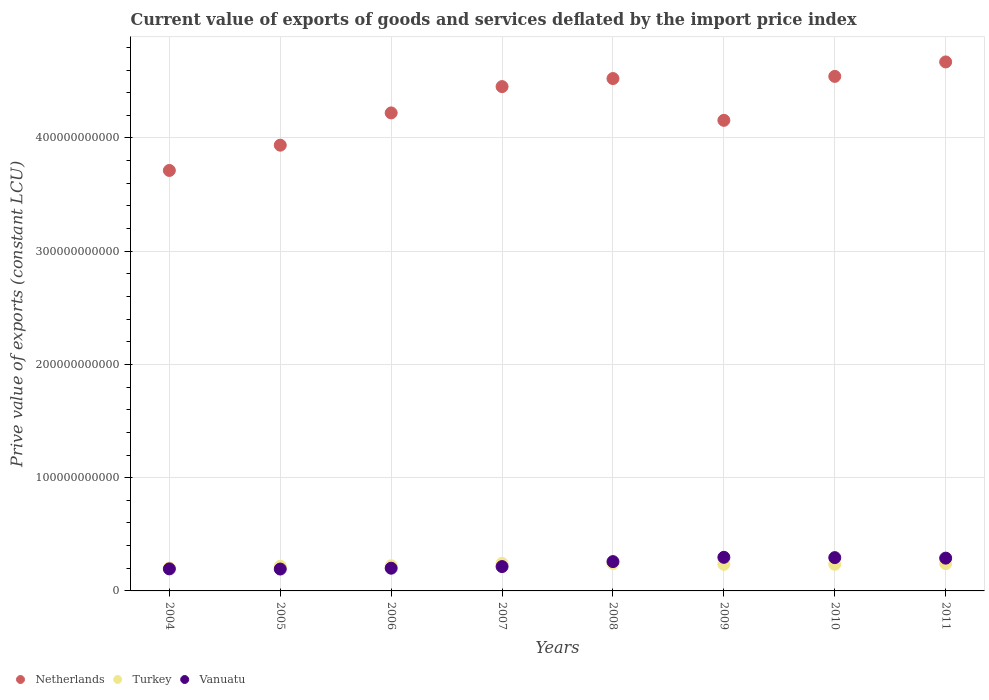How many different coloured dotlines are there?
Your response must be concise. 3. What is the prive value of exports in Turkey in 2010?
Offer a terse response. 2.35e+1. Across all years, what is the maximum prive value of exports in Turkey?
Ensure brevity in your answer.  2.43e+1. Across all years, what is the minimum prive value of exports in Vanuatu?
Provide a succinct answer. 1.93e+1. In which year was the prive value of exports in Vanuatu minimum?
Offer a very short reply. 2005. What is the total prive value of exports in Vanuatu in the graph?
Your answer should be very brief. 1.94e+11. What is the difference between the prive value of exports in Vanuatu in 2007 and that in 2008?
Provide a succinct answer. -4.38e+09. What is the difference between the prive value of exports in Turkey in 2011 and the prive value of exports in Vanuatu in 2007?
Make the answer very short. 2.60e+09. What is the average prive value of exports in Vanuatu per year?
Offer a terse response. 2.43e+1. In the year 2005, what is the difference between the prive value of exports in Vanuatu and prive value of exports in Turkey?
Ensure brevity in your answer.  -2.48e+09. What is the ratio of the prive value of exports in Turkey in 2004 to that in 2006?
Your answer should be very brief. 0.91. Is the prive value of exports in Vanuatu in 2005 less than that in 2006?
Provide a succinct answer. Yes. What is the difference between the highest and the second highest prive value of exports in Vanuatu?
Offer a terse response. 2.61e+08. What is the difference between the highest and the lowest prive value of exports in Turkey?
Provide a short and direct response. 4.02e+09. In how many years, is the prive value of exports in Vanuatu greater than the average prive value of exports in Vanuatu taken over all years?
Offer a very short reply. 4. Is it the case that in every year, the sum of the prive value of exports in Vanuatu and prive value of exports in Netherlands  is greater than the prive value of exports in Turkey?
Your response must be concise. Yes. What is the difference between two consecutive major ticks on the Y-axis?
Offer a very short reply. 1.00e+11. Where does the legend appear in the graph?
Your response must be concise. Bottom left. How many legend labels are there?
Make the answer very short. 3. What is the title of the graph?
Provide a succinct answer. Current value of exports of goods and services deflated by the import price index. Does "Cameroon" appear as one of the legend labels in the graph?
Provide a succinct answer. No. What is the label or title of the Y-axis?
Give a very brief answer. Prive value of exports (constant LCU). What is the Prive value of exports (constant LCU) of Netherlands in 2004?
Offer a terse response. 3.71e+11. What is the Prive value of exports (constant LCU) of Turkey in 2004?
Your response must be concise. 2.03e+1. What is the Prive value of exports (constant LCU) in Vanuatu in 2004?
Keep it short and to the point. 1.95e+1. What is the Prive value of exports (constant LCU) of Netherlands in 2005?
Give a very brief answer. 3.94e+11. What is the Prive value of exports (constant LCU) in Turkey in 2005?
Provide a succinct answer. 2.18e+1. What is the Prive value of exports (constant LCU) of Vanuatu in 2005?
Give a very brief answer. 1.93e+1. What is the Prive value of exports (constant LCU) of Netherlands in 2006?
Keep it short and to the point. 4.22e+11. What is the Prive value of exports (constant LCU) of Turkey in 2006?
Your response must be concise. 2.22e+1. What is the Prive value of exports (constant LCU) in Vanuatu in 2006?
Offer a very short reply. 2.01e+1. What is the Prive value of exports (constant LCU) of Netherlands in 2007?
Keep it short and to the point. 4.45e+11. What is the Prive value of exports (constant LCU) in Turkey in 2007?
Make the answer very short. 2.43e+1. What is the Prive value of exports (constant LCU) in Vanuatu in 2007?
Keep it short and to the point. 2.15e+1. What is the Prive value of exports (constant LCU) of Netherlands in 2008?
Offer a very short reply. 4.52e+11. What is the Prive value of exports (constant LCU) in Turkey in 2008?
Ensure brevity in your answer.  2.42e+1. What is the Prive value of exports (constant LCU) in Vanuatu in 2008?
Your answer should be compact. 2.59e+1. What is the Prive value of exports (constant LCU) in Netherlands in 2009?
Your answer should be compact. 4.16e+11. What is the Prive value of exports (constant LCU) in Turkey in 2009?
Provide a short and direct response. 2.35e+1. What is the Prive value of exports (constant LCU) of Vanuatu in 2009?
Ensure brevity in your answer.  2.97e+1. What is the Prive value of exports (constant LCU) in Netherlands in 2010?
Make the answer very short. 4.54e+11. What is the Prive value of exports (constant LCU) in Turkey in 2010?
Offer a terse response. 2.35e+1. What is the Prive value of exports (constant LCU) of Vanuatu in 2010?
Offer a very short reply. 2.94e+1. What is the Prive value of exports (constant LCU) of Netherlands in 2011?
Offer a terse response. 4.67e+11. What is the Prive value of exports (constant LCU) of Turkey in 2011?
Keep it short and to the point. 2.41e+1. What is the Prive value of exports (constant LCU) of Vanuatu in 2011?
Offer a very short reply. 2.90e+1. Across all years, what is the maximum Prive value of exports (constant LCU) in Netherlands?
Give a very brief answer. 4.67e+11. Across all years, what is the maximum Prive value of exports (constant LCU) in Turkey?
Give a very brief answer. 2.43e+1. Across all years, what is the maximum Prive value of exports (constant LCU) of Vanuatu?
Offer a terse response. 2.97e+1. Across all years, what is the minimum Prive value of exports (constant LCU) in Netherlands?
Ensure brevity in your answer.  3.71e+11. Across all years, what is the minimum Prive value of exports (constant LCU) of Turkey?
Ensure brevity in your answer.  2.03e+1. Across all years, what is the minimum Prive value of exports (constant LCU) of Vanuatu?
Give a very brief answer. 1.93e+1. What is the total Prive value of exports (constant LCU) of Netherlands in the graph?
Keep it short and to the point. 3.42e+12. What is the total Prive value of exports (constant LCU) of Turkey in the graph?
Your response must be concise. 1.84e+11. What is the total Prive value of exports (constant LCU) in Vanuatu in the graph?
Offer a very short reply. 1.94e+11. What is the difference between the Prive value of exports (constant LCU) of Netherlands in 2004 and that in 2005?
Make the answer very short. -2.23e+1. What is the difference between the Prive value of exports (constant LCU) in Turkey in 2004 and that in 2005?
Your answer should be very brief. -1.52e+09. What is the difference between the Prive value of exports (constant LCU) in Vanuatu in 2004 and that in 2005?
Give a very brief answer. 1.50e+08. What is the difference between the Prive value of exports (constant LCU) of Netherlands in 2004 and that in 2006?
Your answer should be compact. -5.08e+1. What is the difference between the Prive value of exports (constant LCU) of Turkey in 2004 and that in 2006?
Your response must be concise. -1.94e+09. What is the difference between the Prive value of exports (constant LCU) of Vanuatu in 2004 and that in 2006?
Provide a short and direct response. -5.93e+08. What is the difference between the Prive value of exports (constant LCU) in Netherlands in 2004 and that in 2007?
Give a very brief answer. -7.41e+1. What is the difference between the Prive value of exports (constant LCU) in Turkey in 2004 and that in 2007?
Your answer should be very brief. -4.02e+09. What is the difference between the Prive value of exports (constant LCU) in Vanuatu in 2004 and that in 2007?
Provide a short and direct response. -2.04e+09. What is the difference between the Prive value of exports (constant LCU) of Netherlands in 2004 and that in 2008?
Your answer should be very brief. -8.12e+1. What is the difference between the Prive value of exports (constant LCU) of Turkey in 2004 and that in 2008?
Keep it short and to the point. -3.92e+09. What is the difference between the Prive value of exports (constant LCU) in Vanuatu in 2004 and that in 2008?
Your answer should be very brief. -6.42e+09. What is the difference between the Prive value of exports (constant LCU) in Netherlands in 2004 and that in 2009?
Give a very brief answer. -4.43e+1. What is the difference between the Prive value of exports (constant LCU) in Turkey in 2004 and that in 2009?
Offer a terse response. -3.19e+09. What is the difference between the Prive value of exports (constant LCU) in Vanuatu in 2004 and that in 2009?
Give a very brief answer. -1.02e+1. What is the difference between the Prive value of exports (constant LCU) of Netherlands in 2004 and that in 2010?
Make the answer very short. -8.31e+1. What is the difference between the Prive value of exports (constant LCU) in Turkey in 2004 and that in 2010?
Provide a succinct answer. -3.24e+09. What is the difference between the Prive value of exports (constant LCU) of Vanuatu in 2004 and that in 2010?
Your response must be concise. -9.94e+09. What is the difference between the Prive value of exports (constant LCU) in Netherlands in 2004 and that in 2011?
Offer a terse response. -9.59e+1. What is the difference between the Prive value of exports (constant LCU) of Turkey in 2004 and that in 2011?
Make the answer very short. -3.84e+09. What is the difference between the Prive value of exports (constant LCU) in Vanuatu in 2004 and that in 2011?
Make the answer very short. -9.48e+09. What is the difference between the Prive value of exports (constant LCU) of Netherlands in 2005 and that in 2006?
Your response must be concise. -2.85e+1. What is the difference between the Prive value of exports (constant LCU) of Turkey in 2005 and that in 2006?
Provide a succinct answer. -4.16e+08. What is the difference between the Prive value of exports (constant LCU) of Vanuatu in 2005 and that in 2006?
Your response must be concise. -7.43e+08. What is the difference between the Prive value of exports (constant LCU) in Netherlands in 2005 and that in 2007?
Keep it short and to the point. -5.17e+1. What is the difference between the Prive value of exports (constant LCU) of Turkey in 2005 and that in 2007?
Provide a succinct answer. -2.49e+09. What is the difference between the Prive value of exports (constant LCU) in Vanuatu in 2005 and that in 2007?
Ensure brevity in your answer.  -2.19e+09. What is the difference between the Prive value of exports (constant LCU) of Netherlands in 2005 and that in 2008?
Ensure brevity in your answer.  -5.88e+1. What is the difference between the Prive value of exports (constant LCU) in Turkey in 2005 and that in 2008?
Give a very brief answer. -2.39e+09. What is the difference between the Prive value of exports (constant LCU) of Vanuatu in 2005 and that in 2008?
Make the answer very short. -6.57e+09. What is the difference between the Prive value of exports (constant LCU) in Netherlands in 2005 and that in 2009?
Provide a short and direct response. -2.19e+1. What is the difference between the Prive value of exports (constant LCU) in Turkey in 2005 and that in 2009?
Make the answer very short. -1.66e+09. What is the difference between the Prive value of exports (constant LCU) in Vanuatu in 2005 and that in 2009?
Keep it short and to the point. -1.04e+1. What is the difference between the Prive value of exports (constant LCU) of Netherlands in 2005 and that in 2010?
Your answer should be compact. -6.08e+1. What is the difference between the Prive value of exports (constant LCU) in Turkey in 2005 and that in 2010?
Your answer should be compact. -1.71e+09. What is the difference between the Prive value of exports (constant LCU) of Vanuatu in 2005 and that in 2010?
Your answer should be compact. -1.01e+1. What is the difference between the Prive value of exports (constant LCU) in Netherlands in 2005 and that in 2011?
Offer a very short reply. -7.35e+1. What is the difference between the Prive value of exports (constant LCU) in Turkey in 2005 and that in 2011?
Provide a succinct answer. -2.31e+09. What is the difference between the Prive value of exports (constant LCU) in Vanuatu in 2005 and that in 2011?
Provide a succinct answer. -9.63e+09. What is the difference between the Prive value of exports (constant LCU) of Netherlands in 2006 and that in 2007?
Your response must be concise. -2.32e+1. What is the difference between the Prive value of exports (constant LCU) in Turkey in 2006 and that in 2007?
Your answer should be very brief. -2.08e+09. What is the difference between the Prive value of exports (constant LCU) in Vanuatu in 2006 and that in 2007?
Give a very brief answer. -1.45e+09. What is the difference between the Prive value of exports (constant LCU) of Netherlands in 2006 and that in 2008?
Give a very brief answer. -3.03e+1. What is the difference between the Prive value of exports (constant LCU) of Turkey in 2006 and that in 2008?
Your answer should be very brief. -1.97e+09. What is the difference between the Prive value of exports (constant LCU) in Vanuatu in 2006 and that in 2008?
Your answer should be very brief. -5.82e+09. What is the difference between the Prive value of exports (constant LCU) in Netherlands in 2006 and that in 2009?
Make the answer very short. 6.55e+09. What is the difference between the Prive value of exports (constant LCU) of Turkey in 2006 and that in 2009?
Offer a very short reply. -1.25e+09. What is the difference between the Prive value of exports (constant LCU) in Vanuatu in 2006 and that in 2009?
Your response must be concise. -9.61e+09. What is the difference between the Prive value of exports (constant LCU) of Netherlands in 2006 and that in 2010?
Give a very brief answer. -3.23e+1. What is the difference between the Prive value of exports (constant LCU) of Turkey in 2006 and that in 2010?
Give a very brief answer. -1.29e+09. What is the difference between the Prive value of exports (constant LCU) of Vanuatu in 2006 and that in 2010?
Ensure brevity in your answer.  -9.35e+09. What is the difference between the Prive value of exports (constant LCU) in Netherlands in 2006 and that in 2011?
Provide a short and direct response. -4.50e+1. What is the difference between the Prive value of exports (constant LCU) in Turkey in 2006 and that in 2011?
Make the answer very short. -1.90e+09. What is the difference between the Prive value of exports (constant LCU) in Vanuatu in 2006 and that in 2011?
Your response must be concise. -8.89e+09. What is the difference between the Prive value of exports (constant LCU) in Netherlands in 2007 and that in 2008?
Provide a succinct answer. -7.11e+09. What is the difference between the Prive value of exports (constant LCU) of Turkey in 2007 and that in 2008?
Provide a short and direct response. 1.04e+08. What is the difference between the Prive value of exports (constant LCU) in Vanuatu in 2007 and that in 2008?
Your answer should be compact. -4.38e+09. What is the difference between the Prive value of exports (constant LCU) in Netherlands in 2007 and that in 2009?
Offer a very short reply. 2.98e+1. What is the difference between the Prive value of exports (constant LCU) in Turkey in 2007 and that in 2009?
Offer a very short reply. 8.31e+08. What is the difference between the Prive value of exports (constant LCU) in Vanuatu in 2007 and that in 2009?
Make the answer very short. -8.16e+09. What is the difference between the Prive value of exports (constant LCU) of Netherlands in 2007 and that in 2010?
Give a very brief answer. -9.02e+09. What is the difference between the Prive value of exports (constant LCU) of Turkey in 2007 and that in 2010?
Your answer should be very brief. 7.84e+08. What is the difference between the Prive value of exports (constant LCU) of Vanuatu in 2007 and that in 2010?
Make the answer very short. -7.90e+09. What is the difference between the Prive value of exports (constant LCU) of Netherlands in 2007 and that in 2011?
Your response must be concise. -2.18e+1. What is the difference between the Prive value of exports (constant LCU) in Turkey in 2007 and that in 2011?
Your answer should be very brief. 1.84e+08. What is the difference between the Prive value of exports (constant LCU) of Vanuatu in 2007 and that in 2011?
Give a very brief answer. -7.44e+09. What is the difference between the Prive value of exports (constant LCU) in Netherlands in 2008 and that in 2009?
Provide a succinct answer. 3.69e+1. What is the difference between the Prive value of exports (constant LCU) in Turkey in 2008 and that in 2009?
Ensure brevity in your answer.  7.27e+08. What is the difference between the Prive value of exports (constant LCU) in Vanuatu in 2008 and that in 2009?
Your response must be concise. -3.78e+09. What is the difference between the Prive value of exports (constant LCU) in Netherlands in 2008 and that in 2010?
Provide a short and direct response. -1.91e+09. What is the difference between the Prive value of exports (constant LCU) in Turkey in 2008 and that in 2010?
Your answer should be very brief. 6.80e+08. What is the difference between the Prive value of exports (constant LCU) in Vanuatu in 2008 and that in 2010?
Your answer should be very brief. -3.52e+09. What is the difference between the Prive value of exports (constant LCU) in Netherlands in 2008 and that in 2011?
Give a very brief answer. -1.47e+1. What is the difference between the Prive value of exports (constant LCU) of Turkey in 2008 and that in 2011?
Provide a succinct answer. 7.95e+07. What is the difference between the Prive value of exports (constant LCU) of Vanuatu in 2008 and that in 2011?
Your answer should be very brief. -3.06e+09. What is the difference between the Prive value of exports (constant LCU) of Netherlands in 2009 and that in 2010?
Your answer should be compact. -3.88e+1. What is the difference between the Prive value of exports (constant LCU) in Turkey in 2009 and that in 2010?
Make the answer very short. -4.73e+07. What is the difference between the Prive value of exports (constant LCU) of Vanuatu in 2009 and that in 2010?
Offer a very short reply. 2.61e+08. What is the difference between the Prive value of exports (constant LCU) of Netherlands in 2009 and that in 2011?
Make the answer very short. -5.16e+1. What is the difference between the Prive value of exports (constant LCU) of Turkey in 2009 and that in 2011?
Offer a terse response. -6.48e+08. What is the difference between the Prive value of exports (constant LCU) of Vanuatu in 2009 and that in 2011?
Make the answer very short. 7.20e+08. What is the difference between the Prive value of exports (constant LCU) of Netherlands in 2010 and that in 2011?
Your response must be concise. -1.28e+1. What is the difference between the Prive value of exports (constant LCU) in Turkey in 2010 and that in 2011?
Provide a short and direct response. -6.00e+08. What is the difference between the Prive value of exports (constant LCU) of Vanuatu in 2010 and that in 2011?
Give a very brief answer. 4.59e+08. What is the difference between the Prive value of exports (constant LCU) in Netherlands in 2004 and the Prive value of exports (constant LCU) in Turkey in 2005?
Your answer should be very brief. 3.50e+11. What is the difference between the Prive value of exports (constant LCU) in Netherlands in 2004 and the Prive value of exports (constant LCU) in Vanuatu in 2005?
Offer a very short reply. 3.52e+11. What is the difference between the Prive value of exports (constant LCU) of Turkey in 2004 and the Prive value of exports (constant LCU) of Vanuatu in 2005?
Keep it short and to the point. 9.57e+08. What is the difference between the Prive value of exports (constant LCU) in Netherlands in 2004 and the Prive value of exports (constant LCU) in Turkey in 2006?
Ensure brevity in your answer.  3.49e+11. What is the difference between the Prive value of exports (constant LCU) in Netherlands in 2004 and the Prive value of exports (constant LCU) in Vanuatu in 2006?
Make the answer very short. 3.51e+11. What is the difference between the Prive value of exports (constant LCU) of Turkey in 2004 and the Prive value of exports (constant LCU) of Vanuatu in 2006?
Offer a terse response. 2.14e+08. What is the difference between the Prive value of exports (constant LCU) of Netherlands in 2004 and the Prive value of exports (constant LCU) of Turkey in 2007?
Provide a succinct answer. 3.47e+11. What is the difference between the Prive value of exports (constant LCU) of Netherlands in 2004 and the Prive value of exports (constant LCU) of Vanuatu in 2007?
Keep it short and to the point. 3.50e+11. What is the difference between the Prive value of exports (constant LCU) of Turkey in 2004 and the Prive value of exports (constant LCU) of Vanuatu in 2007?
Provide a short and direct response. -1.23e+09. What is the difference between the Prive value of exports (constant LCU) in Netherlands in 2004 and the Prive value of exports (constant LCU) in Turkey in 2008?
Offer a very short reply. 3.47e+11. What is the difference between the Prive value of exports (constant LCU) in Netherlands in 2004 and the Prive value of exports (constant LCU) in Vanuatu in 2008?
Your answer should be very brief. 3.45e+11. What is the difference between the Prive value of exports (constant LCU) in Turkey in 2004 and the Prive value of exports (constant LCU) in Vanuatu in 2008?
Your answer should be compact. -5.61e+09. What is the difference between the Prive value of exports (constant LCU) of Netherlands in 2004 and the Prive value of exports (constant LCU) of Turkey in 2009?
Keep it short and to the point. 3.48e+11. What is the difference between the Prive value of exports (constant LCU) in Netherlands in 2004 and the Prive value of exports (constant LCU) in Vanuatu in 2009?
Offer a terse response. 3.42e+11. What is the difference between the Prive value of exports (constant LCU) of Turkey in 2004 and the Prive value of exports (constant LCU) of Vanuatu in 2009?
Give a very brief answer. -9.39e+09. What is the difference between the Prive value of exports (constant LCU) in Netherlands in 2004 and the Prive value of exports (constant LCU) in Turkey in 2010?
Your answer should be compact. 3.48e+11. What is the difference between the Prive value of exports (constant LCU) of Netherlands in 2004 and the Prive value of exports (constant LCU) of Vanuatu in 2010?
Your response must be concise. 3.42e+11. What is the difference between the Prive value of exports (constant LCU) in Turkey in 2004 and the Prive value of exports (constant LCU) in Vanuatu in 2010?
Make the answer very short. -9.13e+09. What is the difference between the Prive value of exports (constant LCU) in Netherlands in 2004 and the Prive value of exports (constant LCU) in Turkey in 2011?
Provide a succinct answer. 3.47e+11. What is the difference between the Prive value of exports (constant LCU) of Netherlands in 2004 and the Prive value of exports (constant LCU) of Vanuatu in 2011?
Ensure brevity in your answer.  3.42e+11. What is the difference between the Prive value of exports (constant LCU) of Turkey in 2004 and the Prive value of exports (constant LCU) of Vanuatu in 2011?
Your answer should be compact. -8.67e+09. What is the difference between the Prive value of exports (constant LCU) in Netherlands in 2005 and the Prive value of exports (constant LCU) in Turkey in 2006?
Provide a short and direct response. 3.71e+11. What is the difference between the Prive value of exports (constant LCU) in Netherlands in 2005 and the Prive value of exports (constant LCU) in Vanuatu in 2006?
Provide a short and direct response. 3.74e+11. What is the difference between the Prive value of exports (constant LCU) in Turkey in 2005 and the Prive value of exports (constant LCU) in Vanuatu in 2006?
Offer a terse response. 1.74e+09. What is the difference between the Prive value of exports (constant LCU) in Netherlands in 2005 and the Prive value of exports (constant LCU) in Turkey in 2007?
Your answer should be very brief. 3.69e+11. What is the difference between the Prive value of exports (constant LCU) in Netherlands in 2005 and the Prive value of exports (constant LCU) in Vanuatu in 2007?
Offer a very short reply. 3.72e+11. What is the difference between the Prive value of exports (constant LCU) of Turkey in 2005 and the Prive value of exports (constant LCU) of Vanuatu in 2007?
Offer a terse response. 2.92e+08. What is the difference between the Prive value of exports (constant LCU) in Netherlands in 2005 and the Prive value of exports (constant LCU) in Turkey in 2008?
Your answer should be very brief. 3.69e+11. What is the difference between the Prive value of exports (constant LCU) of Netherlands in 2005 and the Prive value of exports (constant LCU) of Vanuatu in 2008?
Offer a terse response. 3.68e+11. What is the difference between the Prive value of exports (constant LCU) in Turkey in 2005 and the Prive value of exports (constant LCU) in Vanuatu in 2008?
Make the answer very short. -4.09e+09. What is the difference between the Prive value of exports (constant LCU) of Netherlands in 2005 and the Prive value of exports (constant LCU) of Turkey in 2009?
Provide a succinct answer. 3.70e+11. What is the difference between the Prive value of exports (constant LCU) in Netherlands in 2005 and the Prive value of exports (constant LCU) in Vanuatu in 2009?
Your answer should be very brief. 3.64e+11. What is the difference between the Prive value of exports (constant LCU) of Turkey in 2005 and the Prive value of exports (constant LCU) of Vanuatu in 2009?
Ensure brevity in your answer.  -7.87e+09. What is the difference between the Prive value of exports (constant LCU) in Netherlands in 2005 and the Prive value of exports (constant LCU) in Turkey in 2010?
Offer a terse response. 3.70e+11. What is the difference between the Prive value of exports (constant LCU) in Netherlands in 2005 and the Prive value of exports (constant LCU) in Vanuatu in 2010?
Your answer should be very brief. 3.64e+11. What is the difference between the Prive value of exports (constant LCU) of Turkey in 2005 and the Prive value of exports (constant LCU) of Vanuatu in 2010?
Your response must be concise. -7.61e+09. What is the difference between the Prive value of exports (constant LCU) of Netherlands in 2005 and the Prive value of exports (constant LCU) of Turkey in 2011?
Your answer should be very brief. 3.70e+11. What is the difference between the Prive value of exports (constant LCU) of Netherlands in 2005 and the Prive value of exports (constant LCU) of Vanuatu in 2011?
Make the answer very short. 3.65e+11. What is the difference between the Prive value of exports (constant LCU) of Turkey in 2005 and the Prive value of exports (constant LCU) of Vanuatu in 2011?
Make the answer very short. -7.15e+09. What is the difference between the Prive value of exports (constant LCU) of Netherlands in 2006 and the Prive value of exports (constant LCU) of Turkey in 2007?
Provide a short and direct response. 3.98e+11. What is the difference between the Prive value of exports (constant LCU) of Netherlands in 2006 and the Prive value of exports (constant LCU) of Vanuatu in 2007?
Provide a short and direct response. 4.01e+11. What is the difference between the Prive value of exports (constant LCU) in Turkey in 2006 and the Prive value of exports (constant LCU) in Vanuatu in 2007?
Give a very brief answer. 7.08e+08. What is the difference between the Prive value of exports (constant LCU) in Netherlands in 2006 and the Prive value of exports (constant LCU) in Turkey in 2008?
Make the answer very short. 3.98e+11. What is the difference between the Prive value of exports (constant LCU) of Netherlands in 2006 and the Prive value of exports (constant LCU) of Vanuatu in 2008?
Your answer should be very brief. 3.96e+11. What is the difference between the Prive value of exports (constant LCU) of Turkey in 2006 and the Prive value of exports (constant LCU) of Vanuatu in 2008?
Keep it short and to the point. -3.67e+09. What is the difference between the Prive value of exports (constant LCU) of Netherlands in 2006 and the Prive value of exports (constant LCU) of Turkey in 2009?
Your answer should be very brief. 3.99e+11. What is the difference between the Prive value of exports (constant LCU) in Netherlands in 2006 and the Prive value of exports (constant LCU) in Vanuatu in 2009?
Your answer should be compact. 3.92e+11. What is the difference between the Prive value of exports (constant LCU) of Turkey in 2006 and the Prive value of exports (constant LCU) of Vanuatu in 2009?
Ensure brevity in your answer.  -7.45e+09. What is the difference between the Prive value of exports (constant LCU) of Netherlands in 2006 and the Prive value of exports (constant LCU) of Turkey in 2010?
Ensure brevity in your answer.  3.99e+11. What is the difference between the Prive value of exports (constant LCU) in Netherlands in 2006 and the Prive value of exports (constant LCU) in Vanuatu in 2010?
Ensure brevity in your answer.  3.93e+11. What is the difference between the Prive value of exports (constant LCU) in Turkey in 2006 and the Prive value of exports (constant LCU) in Vanuatu in 2010?
Provide a succinct answer. -7.19e+09. What is the difference between the Prive value of exports (constant LCU) of Netherlands in 2006 and the Prive value of exports (constant LCU) of Turkey in 2011?
Offer a terse response. 3.98e+11. What is the difference between the Prive value of exports (constant LCU) in Netherlands in 2006 and the Prive value of exports (constant LCU) in Vanuatu in 2011?
Offer a very short reply. 3.93e+11. What is the difference between the Prive value of exports (constant LCU) of Turkey in 2006 and the Prive value of exports (constant LCU) of Vanuatu in 2011?
Keep it short and to the point. -6.73e+09. What is the difference between the Prive value of exports (constant LCU) of Netherlands in 2007 and the Prive value of exports (constant LCU) of Turkey in 2008?
Ensure brevity in your answer.  4.21e+11. What is the difference between the Prive value of exports (constant LCU) in Netherlands in 2007 and the Prive value of exports (constant LCU) in Vanuatu in 2008?
Offer a terse response. 4.19e+11. What is the difference between the Prive value of exports (constant LCU) in Turkey in 2007 and the Prive value of exports (constant LCU) in Vanuatu in 2008?
Offer a terse response. -1.59e+09. What is the difference between the Prive value of exports (constant LCU) in Netherlands in 2007 and the Prive value of exports (constant LCU) in Turkey in 2009?
Your response must be concise. 4.22e+11. What is the difference between the Prive value of exports (constant LCU) in Netherlands in 2007 and the Prive value of exports (constant LCU) in Vanuatu in 2009?
Your response must be concise. 4.16e+11. What is the difference between the Prive value of exports (constant LCU) of Turkey in 2007 and the Prive value of exports (constant LCU) of Vanuatu in 2009?
Make the answer very short. -5.37e+09. What is the difference between the Prive value of exports (constant LCU) of Netherlands in 2007 and the Prive value of exports (constant LCU) of Turkey in 2010?
Your response must be concise. 4.22e+11. What is the difference between the Prive value of exports (constant LCU) in Netherlands in 2007 and the Prive value of exports (constant LCU) in Vanuatu in 2010?
Keep it short and to the point. 4.16e+11. What is the difference between the Prive value of exports (constant LCU) in Turkey in 2007 and the Prive value of exports (constant LCU) in Vanuatu in 2010?
Give a very brief answer. -5.11e+09. What is the difference between the Prive value of exports (constant LCU) of Netherlands in 2007 and the Prive value of exports (constant LCU) of Turkey in 2011?
Offer a terse response. 4.21e+11. What is the difference between the Prive value of exports (constant LCU) in Netherlands in 2007 and the Prive value of exports (constant LCU) in Vanuatu in 2011?
Ensure brevity in your answer.  4.16e+11. What is the difference between the Prive value of exports (constant LCU) of Turkey in 2007 and the Prive value of exports (constant LCU) of Vanuatu in 2011?
Provide a succinct answer. -4.65e+09. What is the difference between the Prive value of exports (constant LCU) of Netherlands in 2008 and the Prive value of exports (constant LCU) of Turkey in 2009?
Ensure brevity in your answer.  4.29e+11. What is the difference between the Prive value of exports (constant LCU) in Netherlands in 2008 and the Prive value of exports (constant LCU) in Vanuatu in 2009?
Provide a succinct answer. 4.23e+11. What is the difference between the Prive value of exports (constant LCU) in Turkey in 2008 and the Prive value of exports (constant LCU) in Vanuatu in 2009?
Your answer should be very brief. -5.48e+09. What is the difference between the Prive value of exports (constant LCU) of Netherlands in 2008 and the Prive value of exports (constant LCU) of Turkey in 2010?
Your response must be concise. 4.29e+11. What is the difference between the Prive value of exports (constant LCU) in Netherlands in 2008 and the Prive value of exports (constant LCU) in Vanuatu in 2010?
Your answer should be very brief. 4.23e+11. What is the difference between the Prive value of exports (constant LCU) of Turkey in 2008 and the Prive value of exports (constant LCU) of Vanuatu in 2010?
Provide a succinct answer. -5.22e+09. What is the difference between the Prive value of exports (constant LCU) in Netherlands in 2008 and the Prive value of exports (constant LCU) in Turkey in 2011?
Ensure brevity in your answer.  4.28e+11. What is the difference between the Prive value of exports (constant LCU) of Netherlands in 2008 and the Prive value of exports (constant LCU) of Vanuatu in 2011?
Your answer should be compact. 4.24e+11. What is the difference between the Prive value of exports (constant LCU) of Turkey in 2008 and the Prive value of exports (constant LCU) of Vanuatu in 2011?
Your response must be concise. -4.76e+09. What is the difference between the Prive value of exports (constant LCU) in Netherlands in 2009 and the Prive value of exports (constant LCU) in Turkey in 2010?
Provide a succinct answer. 3.92e+11. What is the difference between the Prive value of exports (constant LCU) of Netherlands in 2009 and the Prive value of exports (constant LCU) of Vanuatu in 2010?
Your answer should be compact. 3.86e+11. What is the difference between the Prive value of exports (constant LCU) of Turkey in 2009 and the Prive value of exports (constant LCU) of Vanuatu in 2010?
Provide a short and direct response. -5.94e+09. What is the difference between the Prive value of exports (constant LCU) of Netherlands in 2009 and the Prive value of exports (constant LCU) of Turkey in 2011?
Offer a very short reply. 3.91e+11. What is the difference between the Prive value of exports (constant LCU) in Netherlands in 2009 and the Prive value of exports (constant LCU) in Vanuatu in 2011?
Provide a short and direct response. 3.87e+11. What is the difference between the Prive value of exports (constant LCU) in Turkey in 2009 and the Prive value of exports (constant LCU) in Vanuatu in 2011?
Your answer should be compact. -5.49e+09. What is the difference between the Prive value of exports (constant LCU) of Netherlands in 2010 and the Prive value of exports (constant LCU) of Turkey in 2011?
Provide a short and direct response. 4.30e+11. What is the difference between the Prive value of exports (constant LCU) in Netherlands in 2010 and the Prive value of exports (constant LCU) in Vanuatu in 2011?
Your answer should be compact. 4.25e+11. What is the difference between the Prive value of exports (constant LCU) in Turkey in 2010 and the Prive value of exports (constant LCU) in Vanuatu in 2011?
Offer a very short reply. -5.44e+09. What is the average Prive value of exports (constant LCU) in Netherlands per year?
Your answer should be compact. 4.28e+11. What is the average Prive value of exports (constant LCU) in Turkey per year?
Your answer should be compact. 2.30e+1. What is the average Prive value of exports (constant LCU) of Vanuatu per year?
Make the answer very short. 2.43e+1. In the year 2004, what is the difference between the Prive value of exports (constant LCU) of Netherlands and Prive value of exports (constant LCU) of Turkey?
Give a very brief answer. 3.51e+11. In the year 2004, what is the difference between the Prive value of exports (constant LCU) in Netherlands and Prive value of exports (constant LCU) in Vanuatu?
Give a very brief answer. 3.52e+11. In the year 2004, what is the difference between the Prive value of exports (constant LCU) in Turkey and Prive value of exports (constant LCU) in Vanuatu?
Ensure brevity in your answer.  8.08e+08. In the year 2005, what is the difference between the Prive value of exports (constant LCU) of Netherlands and Prive value of exports (constant LCU) of Turkey?
Provide a succinct answer. 3.72e+11. In the year 2005, what is the difference between the Prive value of exports (constant LCU) in Netherlands and Prive value of exports (constant LCU) in Vanuatu?
Give a very brief answer. 3.74e+11. In the year 2005, what is the difference between the Prive value of exports (constant LCU) of Turkey and Prive value of exports (constant LCU) of Vanuatu?
Keep it short and to the point. 2.48e+09. In the year 2006, what is the difference between the Prive value of exports (constant LCU) in Netherlands and Prive value of exports (constant LCU) in Turkey?
Your answer should be very brief. 4.00e+11. In the year 2006, what is the difference between the Prive value of exports (constant LCU) of Netherlands and Prive value of exports (constant LCU) of Vanuatu?
Offer a very short reply. 4.02e+11. In the year 2006, what is the difference between the Prive value of exports (constant LCU) of Turkey and Prive value of exports (constant LCU) of Vanuatu?
Offer a terse response. 2.16e+09. In the year 2007, what is the difference between the Prive value of exports (constant LCU) in Netherlands and Prive value of exports (constant LCU) in Turkey?
Give a very brief answer. 4.21e+11. In the year 2007, what is the difference between the Prive value of exports (constant LCU) of Netherlands and Prive value of exports (constant LCU) of Vanuatu?
Give a very brief answer. 4.24e+11. In the year 2007, what is the difference between the Prive value of exports (constant LCU) in Turkey and Prive value of exports (constant LCU) in Vanuatu?
Ensure brevity in your answer.  2.79e+09. In the year 2008, what is the difference between the Prive value of exports (constant LCU) of Netherlands and Prive value of exports (constant LCU) of Turkey?
Offer a very short reply. 4.28e+11. In the year 2008, what is the difference between the Prive value of exports (constant LCU) of Netherlands and Prive value of exports (constant LCU) of Vanuatu?
Your answer should be very brief. 4.27e+11. In the year 2008, what is the difference between the Prive value of exports (constant LCU) of Turkey and Prive value of exports (constant LCU) of Vanuatu?
Offer a terse response. -1.69e+09. In the year 2009, what is the difference between the Prive value of exports (constant LCU) in Netherlands and Prive value of exports (constant LCU) in Turkey?
Make the answer very short. 3.92e+11. In the year 2009, what is the difference between the Prive value of exports (constant LCU) in Netherlands and Prive value of exports (constant LCU) in Vanuatu?
Provide a succinct answer. 3.86e+11. In the year 2009, what is the difference between the Prive value of exports (constant LCU) in Turkey and Prive value of exports (constant LCU) in Vanuatu?
Provide a succinct answer. -6.21e+09. In the year 2010, what is the difference between the Prive value of exports (constant LCU) of Netherlands and Prive value of exports (constant LCU) of Turkey?
Keep it short and to the point. 4.31e+11. In the year 2010, what is the difference between the Prive value of exports (constant LCU) in Netherlands and Prive value of exports (constant LCU) in Vanuatu?
Make the answer very short. 4.25e+11. In the year 2010, what is the difference between the Prive value of exports (constant LCU) of Turkey and Prive value of exports (constant LCU) of Vanuatu?
Make the answer very short. -5.90e+09. In the year 2011, what is the difference between the Prive value of exports (constant LCU) of Netherlands and Prive value of exports (constant LCU) of Turkey?
Give a very brief answer. 4.43e+11. In the year 2011, what is the difference between the Prive value of exports (constant LCU) of Netherlands and Prive value of exports (constant LCU) of Vanuatu?
Your answer should be compact. 4.38e+11. In the year 2011, what is the difference between the Prive value of exports (constant LCU) in Turkey and Prive value of exports (constant LCU) in Vanuatu?
Your answer should be compact. -4.84e+09. What is the ratio of the Prive value of exports (constant LCU) in Netherlands in 2004 to that in 2005?
Your answer should be very brief. 0.94. What is the ratio of the Prive value of exports (constant LCU) of Turkey in 2004 to that in 2005?
Keep it short and to the point. 0.93. What is the ratio of the Prive value of exports (constant LCU) in Vanuatu in 2004 to that in 2005?
Your response must be concise. 1.01. What is the ratio of the Prive value of exports (constant LCU) in Netherlands in 2004 to that in 2006?
Offer a terse response. 0.88. What is the ratio of the Prive value of exports (constant LCU) of Turkey in 2004 to that in 2006?
Provide a succinct answer. 0.91. What is the ratio of the Prive value of exports (constant LCU) of Vanuatu in 2004 to that in 2006?
Give a very brief answer. 0.97. What is the ratio of the Prive value of exports (constant LCU) of Netherlands in 2004 to that in 2007?
Your answer should be very brief. 0.83. What is the ratio of the Prive value of exports (constant LCU) in Turkey in 2004 to that in 2007?
Give a very brief answer. 0.83. What is the ratio of the Prive value of exports (constant LCU) of Vanuatu in 2004 to that in 2007?
Make the answer very short. 0.91. What is the ratio of the Prive value of exports (constant LCU) in Netherlands in 2004 to that in 2008?
Provide a succinct answer. 0.82. What is the ratio of the Prive value of exports (constant LCU) of Turkey in 2004 to that in 2008?
Make the answer very short. 0.84. What is the ratio of the Prive value of exports (constant LCU) in Vanuatu in 2004 to that in 2008?
Provide a succinct answer. 0.75. What is the ratio of the Prive value of exports (constant LCU) in Netherlands in 2004 to that in 2009?
Make the answer very short. 0.89. What is the ratio of the Prive value of exports (constant LCU) in Turkey in 2004 to that in 2009?
Make the answer very short. 0.86. What is the ratio of the Prive value of exports (constant LCU) in Vanuatu in 2004 to that in 2009?
Keep it short and to the point. 0.66. What is the ratio of the Prive value of exports (constant LCU) in Netherlands in 2004 to that in 2010?
Provide a succinct answer. 0.82. What is the ratio of the Prive value of exports (constant LCU) in Turkey in 2004 to that in 2010?
Provide a succinct answer. 0.86. What is the ratio of the Prive value of exports (constant LCU) in Vanuatu in 2004 to that in 2010?
Your answer should be very brief. 0.66. What is the ratio of the Prive value of exports (constant LCU) in Netherlands in 2004 to that in 2011?
Keep it short and to the point. 0.79. What is the ratio of the Prive value of exports (constant LCU) of Turkey in 2004 to that in 2011?
Keep it short and to the point. 0.84. What is the ratio of the Prive value of exports (constant LCU) in Vanuatu in 2004 to that in 2011?
Ensure brevity in your answer.  0.67. What is the ratio of the Prive value of exports (constant LCU) in Netherlands in 2005 to that in 2006?
Provide a short and direct response. 0.93. What is the ratio of the Prive value of exports (constant LCU) of Turkey in 2005 to that in 2006?
Your answer should be compact. 0.98. What is the ratio of the Prive value of exports (constant LCU) of Vanuatu in 2005 to that in 2006?
Make the answer very short. 0.96. What is the ratio of the Prive value of exports (constant LCU) in Netherlands in 2005 to that in 2007?
Offer a terse response. 0.88. What is the ratio of the Prive value of exports (constant LCU) of Turkey in 2005 to that in 2007?
Provide a succinct answer. 0.9. What is the ratio of the Prive value of exports (constant LCU) in Vanuatu in 2005 to that in 2007?
Ensure brevity in your answer.  0.9. What is the ratio of the Prive value of exports (constant LCU) of Netherlands in 2005 to that in 2008?
Provide a short and direct response. 0.87. What is the ratio of the Prive value of exports (constant LCU) of Turkey in 2005 to that in 2008?
Keep it short and to the point. 0.9. What is the ratio of the Prive value of exports (constant LCU) in Vanuatu in 2005 to that in 2008?
Provide a short and direct response. 0.75. What is the ratio of the Prive value of exports (constant LCU) in Netherlands in 2005 to that in 2009?
Make the answer very short. 0.95. What is the ratio of the Prive value of exports (constant LCU) of Turkey in 2005 to that in 2009?
Your answer should be compact. 0.93. What is the ratio of the Prive value of exports (constant LCU) of Vanuatu in 2005 to that in 2009?
Make the answer very short. 0.65. What is the ratio of the Prive value of exports (constant LCU) of Netherlands in 2005 to that in 2010?
Keep it short and to the point. 0.87. What is the ratio of the Prive value of exports (constant LCU) in Turkey in 2005 to that in 2010?
Your answer should be very brief. 0.93. What is the ratio of the Prive value of exports (constant LCU) of Vanuatu in 2005 to that in 2010?
Provide a succinct answer. 0.66. What is the ratio of the Prive value of exports (constant LCU) of Netherlands in 2005 to that in 2011?
Your response must be concise. 0.84. What is the ratio of the Prive value of exports (constant LCU) in Turkey in 2005 to that in 2011?
Make the answer very short. 0.9. What is the ratio of the Prive value of exports (constant LCU) of Vanuatu in 2005 to that in 2011?
Keep it short and to the point. 0.67. What is the ratio of the Prive value of exports (constant LCU) in Netherlands in 2006 to that in 2007?
Give a very brief answer. 0.95. What is the ratio of the Prive value of exports (constant LCU) of Turkey in 2006 to that in 2007?
Give a very brief answer. 0.91. What is the ratio of the Prive value of exports (constant LCU) of Vanuatu in 2006 to that in 2007?
Give a very brief answer. 0.93. What is the ratio of the Prive value of exports (constant LCU) in Netherlands in 2006 to that in 2008?
Make the answer very short. 0.93. What is the ratio of the Prive value of exports (constant LCU) in Turkey in 2006 to that in 2008?
Keep it short and to the point. 0.92. What is the ratio of the Prive value of exports (constant LCU) of Vanuatu in 2006 to that in 2008?
Offer a very short reply. 0.78. What is the ratio of the Prive value of exports (constant LCU) of Netherlands in 2006 to that in 2009?
Your response must be concise. 1.02. What is the ratio of the Prive value of exports (constant LCU) in Turkey in 2006 to that in 2009?
Your answer should be very brief. 0.95. What is the ratio of the Prive value of exports (constant LCU) in Vanuatu in 2006 to that in 2009?
Ensure brevity in your answer.  0.68. What is the ratio of the Prive value of exports (constant LCU) in Netherlands in 2006 to that in 2010?
Your answer should be very brief. 0.93. What is the ratio of the Prive value of exports (constant LCU) of Turkey in 2006 to that in 2010?
Provide a succinct answer. 0.94. What is the ratio of the Prive value of exports (constant LCU) of Vanuatu in 2006 to that in 2010?
Ensure brevity in your answer.  0.68. What is the ratio of the Prive value of exports (constant LCU) of Netherlands in 2006 to that in 2011?
Give a very brief answer. 0.9. What is the ratio of the Prive value of exports (constant LCU) in Turkey in 2006 to that in 2011?
Your answer should be very brief. 0.92. What is the ratio of the Prive value of exports (constant LCU) in Vanuatu in 2006 to that in 2011?
Your response must be concise. 0.69. What is the ratio of the Prive value of exports (constant LCU) in Netherlands in 2007 to that in 2008?
Your answer should be compact. 0.98. What is the ratio of the Prive value of exports (constant LCU) in Turkey in 2007 to that in 2008?
Provide a succinct answer. 1. What is the ratio of the Prive value of exports (constant LCU) of Vanuatu in 2007 to that in 2008?
Your response must be concise. 0.83. What is the ratio of the Prive value of exports (constant LCU) in Netherlands in 2007 to that in 2009?
Your response must be concise. 1.07. What is the ratio of the Prive value of exports (constant LCU) in Turkey in 2007 to that in 2009?
Ensure brevity in your answer.  1.04. What is the ratio of the Prive value of exports (constant LCU) of Vanuatu in 2007 to that in 2009?
Offer a very short reply. 0.72. What is the ratio of the Prive value of exports (constant LCU) of Netherlands in 2007 to that in 2010?
Offer a very short reply. 0.98. What is the ratio of the Prive value of exports (constant LCU) in Vanuatu in 2007 to that in 2010?
Keep it short and to the point. 0.73. What is the ratio of the Prive value of exports (constant LCU) in Netherlands in 2007 to that in 2011?
Ensure brevity in your answer.  0.95. What is the ratio of the Prive value of exports (constant LCU) of Turkey in 2007 to that in 2011?
Make the answer very short. 1.01. What is the ratio of the Prive value of exports (constant LCU) of Vanuatu in 2007 to that in 2011?
Provide a short and direct response. 0.74. What is the ratio of the Prive value of exports (constant LCU) of Netherlands in 2008 to that in 2009?
Keep it short and to the point. 1.09. What is the ratio of the Prive value of exports (constant LCU) in Turkey in 2008 to that in 2009?
Provide a short and direct response. 1.03. What is the ratio of the Prive value of exports (constant LCU) in Vanuatu in 2008 to that in 2009?
Offer a terse response. 0.87. What is the ratio of the Prive value of exports (constant LCU) of Turkey in 2008 to that in 2010?
Offer a terse response. 1.03. What is the ratio of the Prive value of exports (constant LCU) of Vanuatu in 2008 to that in 2010?
Ensure brevity in your answer.  0.88. What is the ratio of the Prive value of exports (constant LCU) of Netherlands in 2008 to that in 2011?
Your response must be concise. 0.97. What is the ratio of the Prive value of exports (constant LCU) of Vanuatu in 2008 to that in 2011?
Make the answer very short. 0.89. What is the ratio of the Prive value of exports (constant LCU) in Netherlands in 2009 to that in 2010?
Give a very brief answer. 0.91. What is the ratio of the Prive value of exports (constant LCU) of Turkey in 2009 to that in 2010?
Offer a terse response. 1. What is the ratio of the Prive value of exports (constant LCU) of Vanuatu in 2009 to that in 2010?
Offer a very short reply. 1.01. What is the ratio of the Prive value of exports (constant LCU) in Netherlands in 2009 to that in 2011?
Offer a very short reply. 0.89. What is the ratio of the Prive value of exports (constant LCU) in Turkey in 2009 to that in 2011?
Offer a very short reply. 0.97. What is the ratio of the Prive value of exports (constant LCU) in Vanuatu in 2009 to that in 2011?
Offer a very short reply. 1.02. What is the ratio of the Prive value of exports (constant LCU) in Netherlands in 2010 to that in 2011?
Offer a terse response. 0.97. What is the ratio of the Prive value of exports (constant LCU) of Turkey in 2010 to that in 2011?
Ensure brevity in your answer.  0.98. What is the ratio of the Prive value of exports (constant LCU) of Vanuatu in 2010 to that in 2011?
Ensure brevity in your answer.  1.02. What is the difference between the highest and the second highest Prive value of exports (constant LCU) in Netherlands?
Your answer should be compact. 1.28e+1. What is the difference between the highest and the second highest Prive value of exports (constant LCU) of Turkey?
Your response must be concise. 1.04e+08. What is the difference between the highest and the second highest Prive value of exports (constant LCU) of Vanuatu?
Give a very brief answer. 2.61e+08. What is the difference between the highest and the lowest Prive value of exports (constant LCU) in Netherlands?
Provide a short and direct response. 9.59e+1. What is the difference between the highest and the lowest Prive value of exports (constant LCU) of Turkey?
Your answer should be compact. 4.02e+09. What is the difference between the highest and the lowest Prive value of exports (constant LCU) of Vanuatu?
Ensure brevity in your answer.  1.04e+1. 